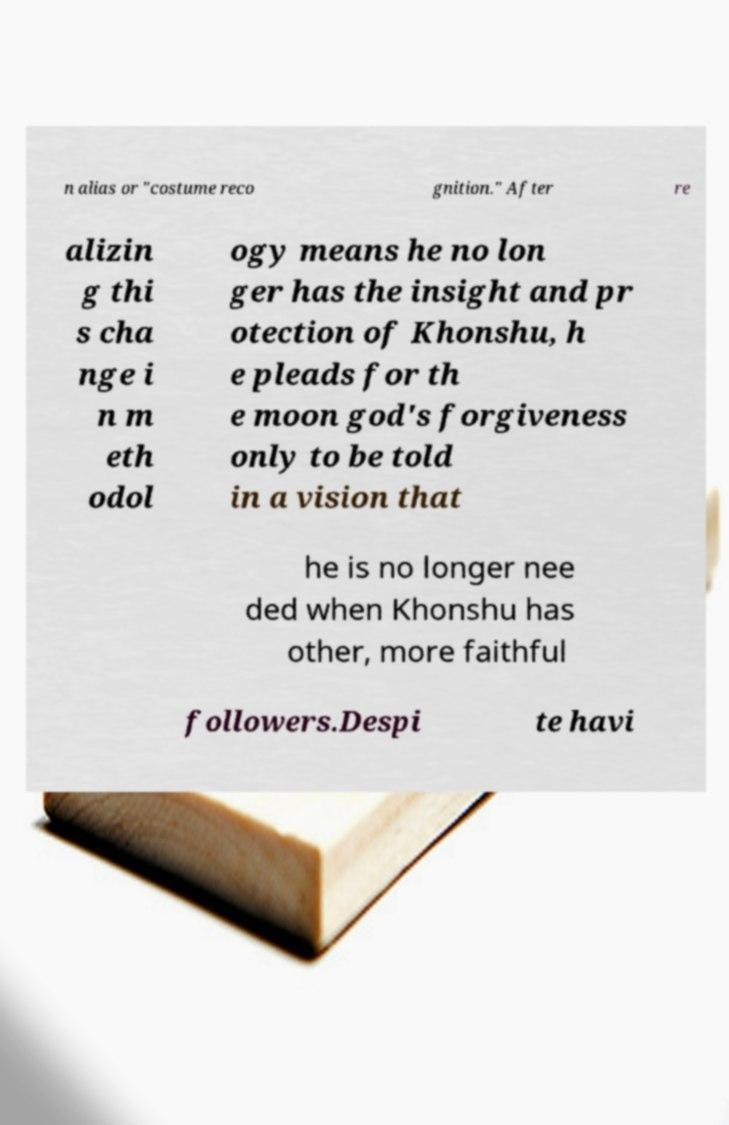There's text embedded in this image that I need extracted. Can you transcribe it verbatim? n alias or "costume reco gnition." After re alizin g thi s cha nge i n m eth odol ogy means he no lon ger has the insight and pr otection of Khonshu, h e pleads for th e moon god's forgiveness only to be told in a vision that he is no longer nee ded when Khonshu has other, more faithful followers.Despi te havi 